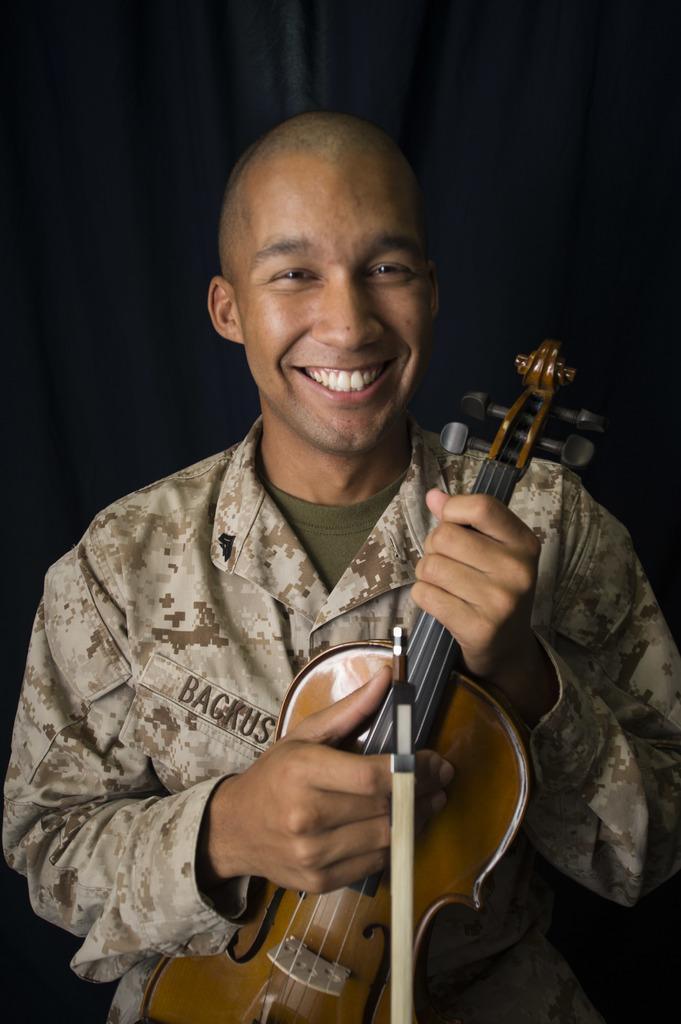Could you give a brief overview of what you see in this image? In the picture we can find a man standing and holding guitar and he is smiling, background we can find a curtain, he wore a shirt which is designed. 